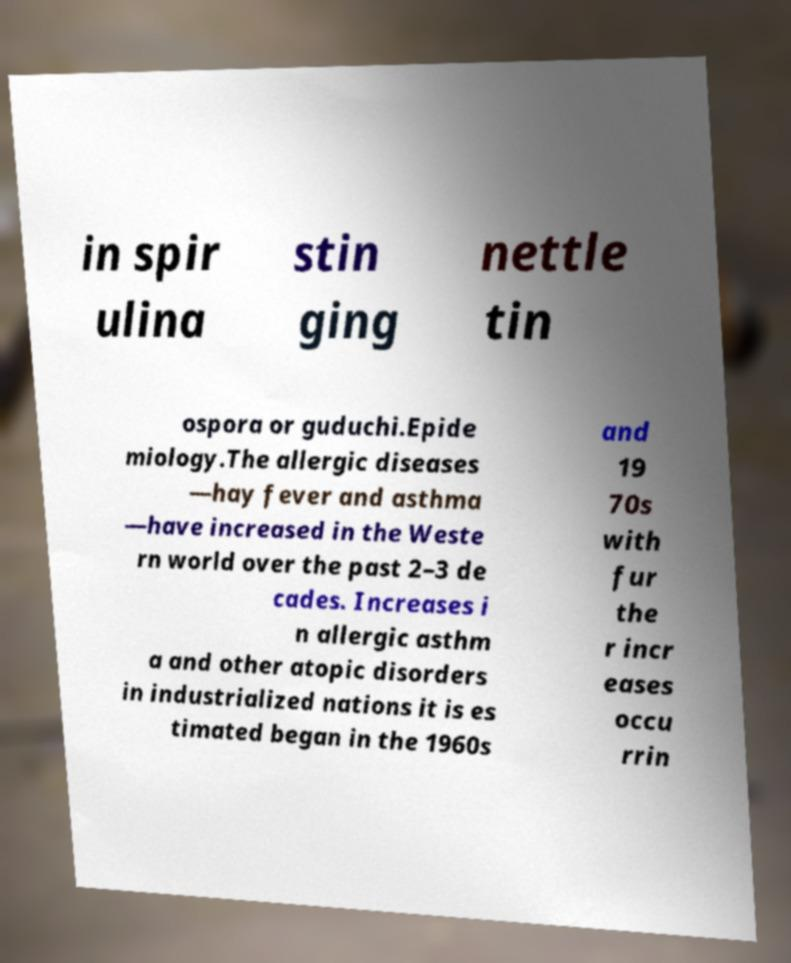Can you accurately transcribe the text from the provided image for me? in spir ulina stin ging nettle tin ospora or guduchi.Epide miology.The allergic diseases —hay fever and asthma —have increased in the Weste rn world over the past 2–3 de cades. Increases i n allergic asthm a and other atopic disorders in industrialized nations it is es timated began in the 1960s and 19 70s with fur the r incr eases occu rrin 